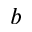<formula> <loc_0><loc_0><loc_500><loc_500>b</formula> 